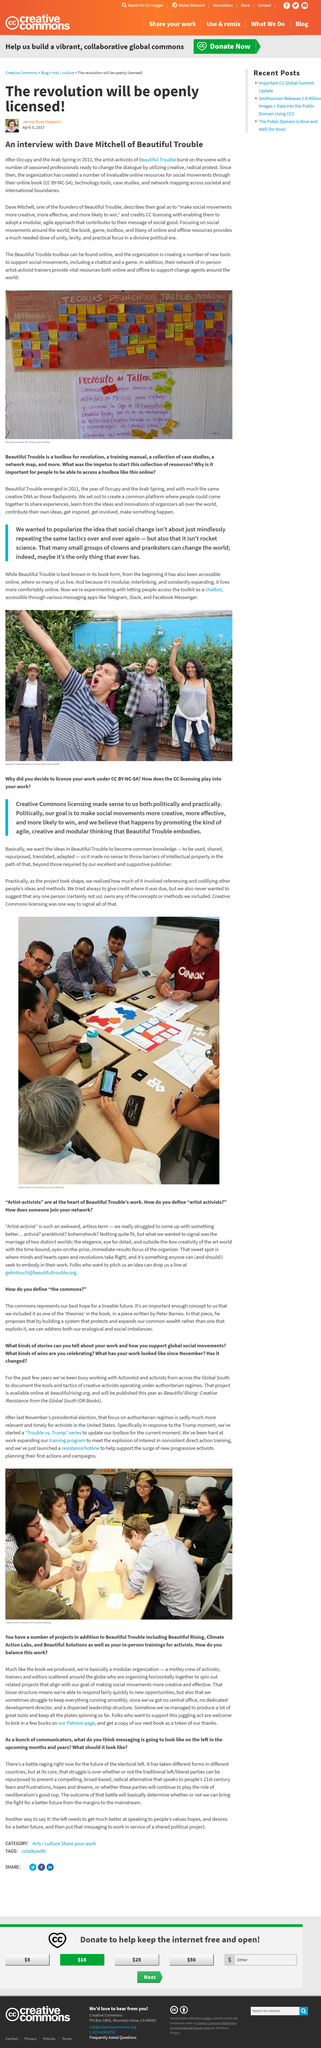Highlight a few significant elements in this photo. The battle is for the future of the electoral left. The online book is called 'CC BY-NC-SA'. Being asked is a bunch of communicators. The article was published six years after the Arab Spring. The traditional left consists of liberal parties who promote progressive policies and social justice. 